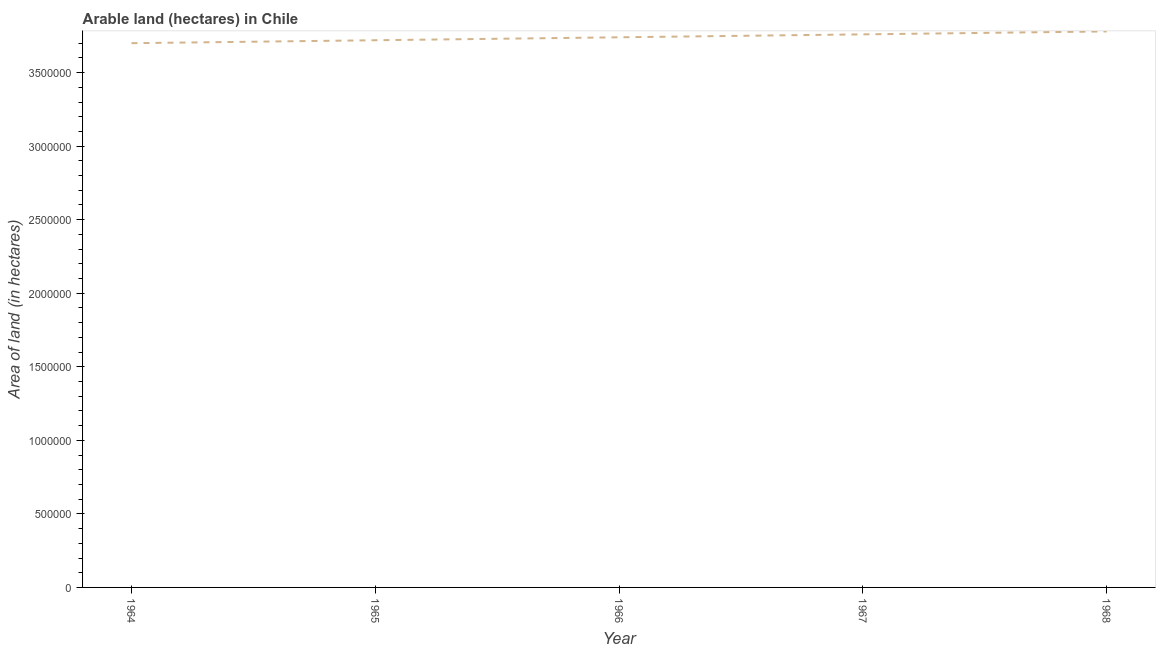What is the area of land in 1965?
Offer a terse response. 3.72e+06. Across all years, what is the maximum area of land?
Offer a terse response. 3.78e+06. Across all years, what is the minimum area of land?
Provide a short and direct response. 3.70e+06. In which year was the area of land maximum?
Give a very brief answer. 1968. In which year was the area of land minimum?
Your response must be concise. 1964. What is the sum of the area of land?
Provide a succinct answer. 1.87e+07. What is the difference between the area of land in 1965 and 1968?
Your answer should be very brief. -6.00e+04. What is the average area of land per year?
Ensure brevity in your answer.  3.74e+06. What is the median area of land?
Provide a short and direct response. 3.74e+06. Do a majority of the years between 1967 and 1965 (inclusive) have area of land greater than 1300000 hectares?
Give a very brief answer. No. What is the ratio of the area of land in 1966 to that in 1967?
Your answer should be compact. 0.99. Is the area of land in 1965 less than that in 1966?
Your answer should be very brief. Yes. Is the difference between the area of land in 1965 and 1966 greater than the difference between any two years?
Your answer should be very brief. No. What is the difference between the highest and the second highest area of land?
Provide a short and direct response. 2.00e+04. Is the sum of the area of land in 1965 and 1968 greater than the maximum area of land across all years?
Your response must be concise. Yes. What is the difference between the highest and the lowest area of land?
Provide a succinct answer. 8.00e+04. Does the area of land monotonically increase over the years?
Offer a very short reply. Yes. How many lines are there?
Provide a short and direct response. 1. Are the values on the major ticks of Y-axis written in scientific E-notation?
Your response must be concise. No. Does the graph contain grids?
Provide a succinct answer. No. What is the title of the graph?
Your answer should be compact. Arable land (hectares) in Chile. What is the label or title of the X-axis?
Keep it short and to the point. Year. What is the label or title of the Y-axis?
Offer a terse response. Area of land (in hectares). What is the Area of land (in hectares) in 1964?
Your answer should be very brief. 3.70e+06. What is the Area of land (in hectares) of 1965?
Offer a very short reply. 3.72e+06. What is the Area of land (in hectares) of 1966?
Provide a short and direct response. 3.74e+06. What is the Area of land (in hectares) of 1967?
Your response must be concise. 3.76e+06. What is the Area of land (in hectares) of 1968?
Make the answer very short. 3.78e+06. What is the difference between the Area of land (in hectares) in 1964 and 1965?
Your answer should be compact. -2.00e+04. What is the difference between the Area of land (in hectares) in 1964 and 1966?
Your answer should be very brief. -4.00e+04. What is the difference between the Area of land (in hectares) in 1964 and 1967?
Keep it short and to the point. -6.00e+04. What is the difference between the Area of land (in hectares) in 1965 and 1966?
Your answer should be very brief. -2.00e+04. What is the difference between the Area of land (in hectares) in 1965 and 1967?
Keep it short and to the point. -4.00e+04. What is the difference between the Area of land (in hectares) in 1967 and 1968?
Provide a short and direct response. -2.00e+04. What is the ratio of the Area of land (in hectares) in 1964 to that in 1967?
Ensure brevity in your answer.  0.98. What is the ratio of the Area of land (in hectares) in 1965 to that in 1966?
Offer a very short reply. 0.99. What is the ratio of the Area of land (in hectares) in 1965 to that in 1968?
Make the answer very short. 0.98. What is the ratio of the Area of land (in hectares) in 1966 to that in 1968?
Your answer should be very brief. 0.99. What is the ratio of the Area of land (in hectares) in 1967 to that in 1968?
Your response must be concise. 0.99. 